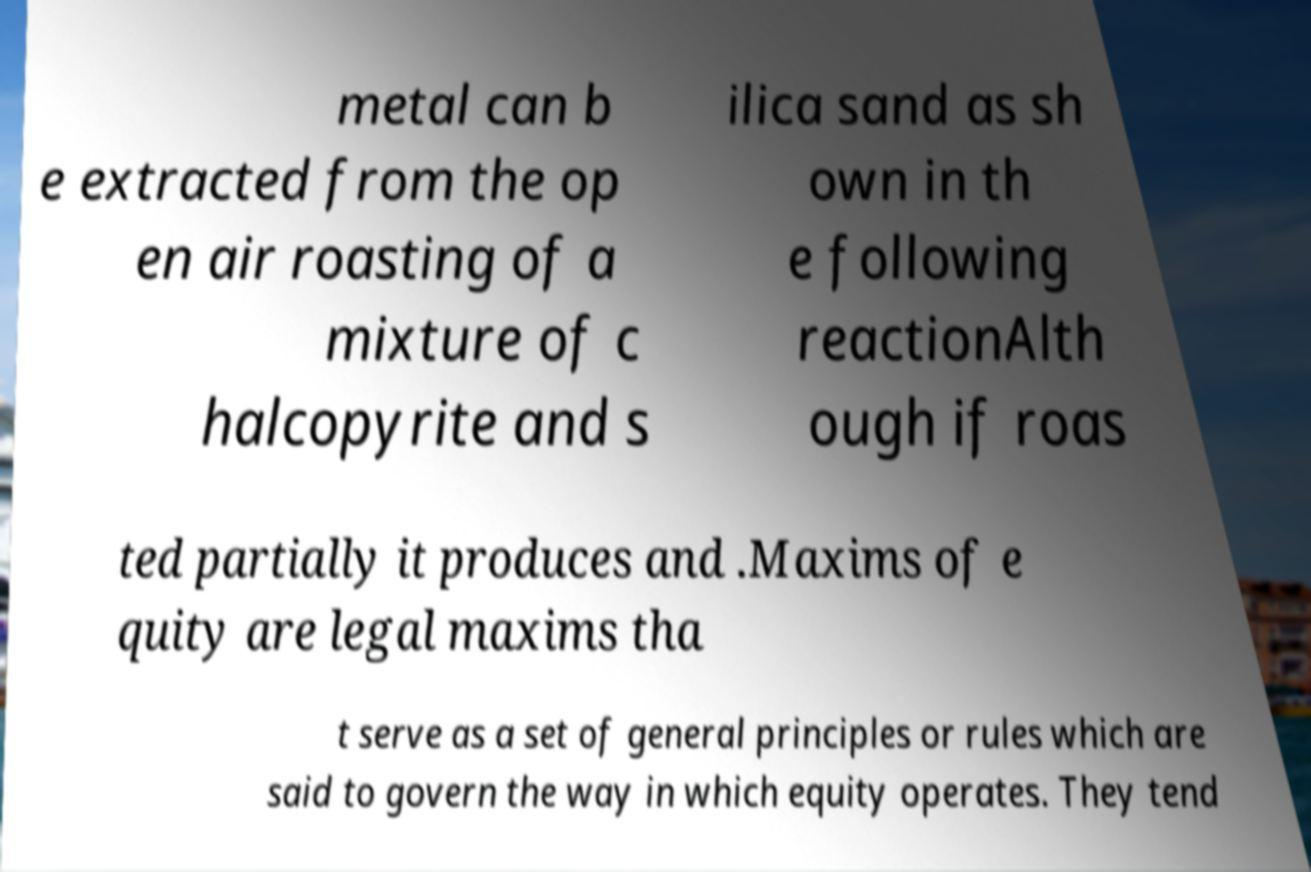Please read and relay the text visible in this image. What does it say? metal can b e extracted from the op en air roasting of a mixture of c halcopyrite and s ilica sand as sh own in th e following reactionAlth ough if roas ted partially it produces and .Maxims of e quity are legal maxims tha t serve as a set of general principles or rules which are said to govern the way in which equity operates. They tend 